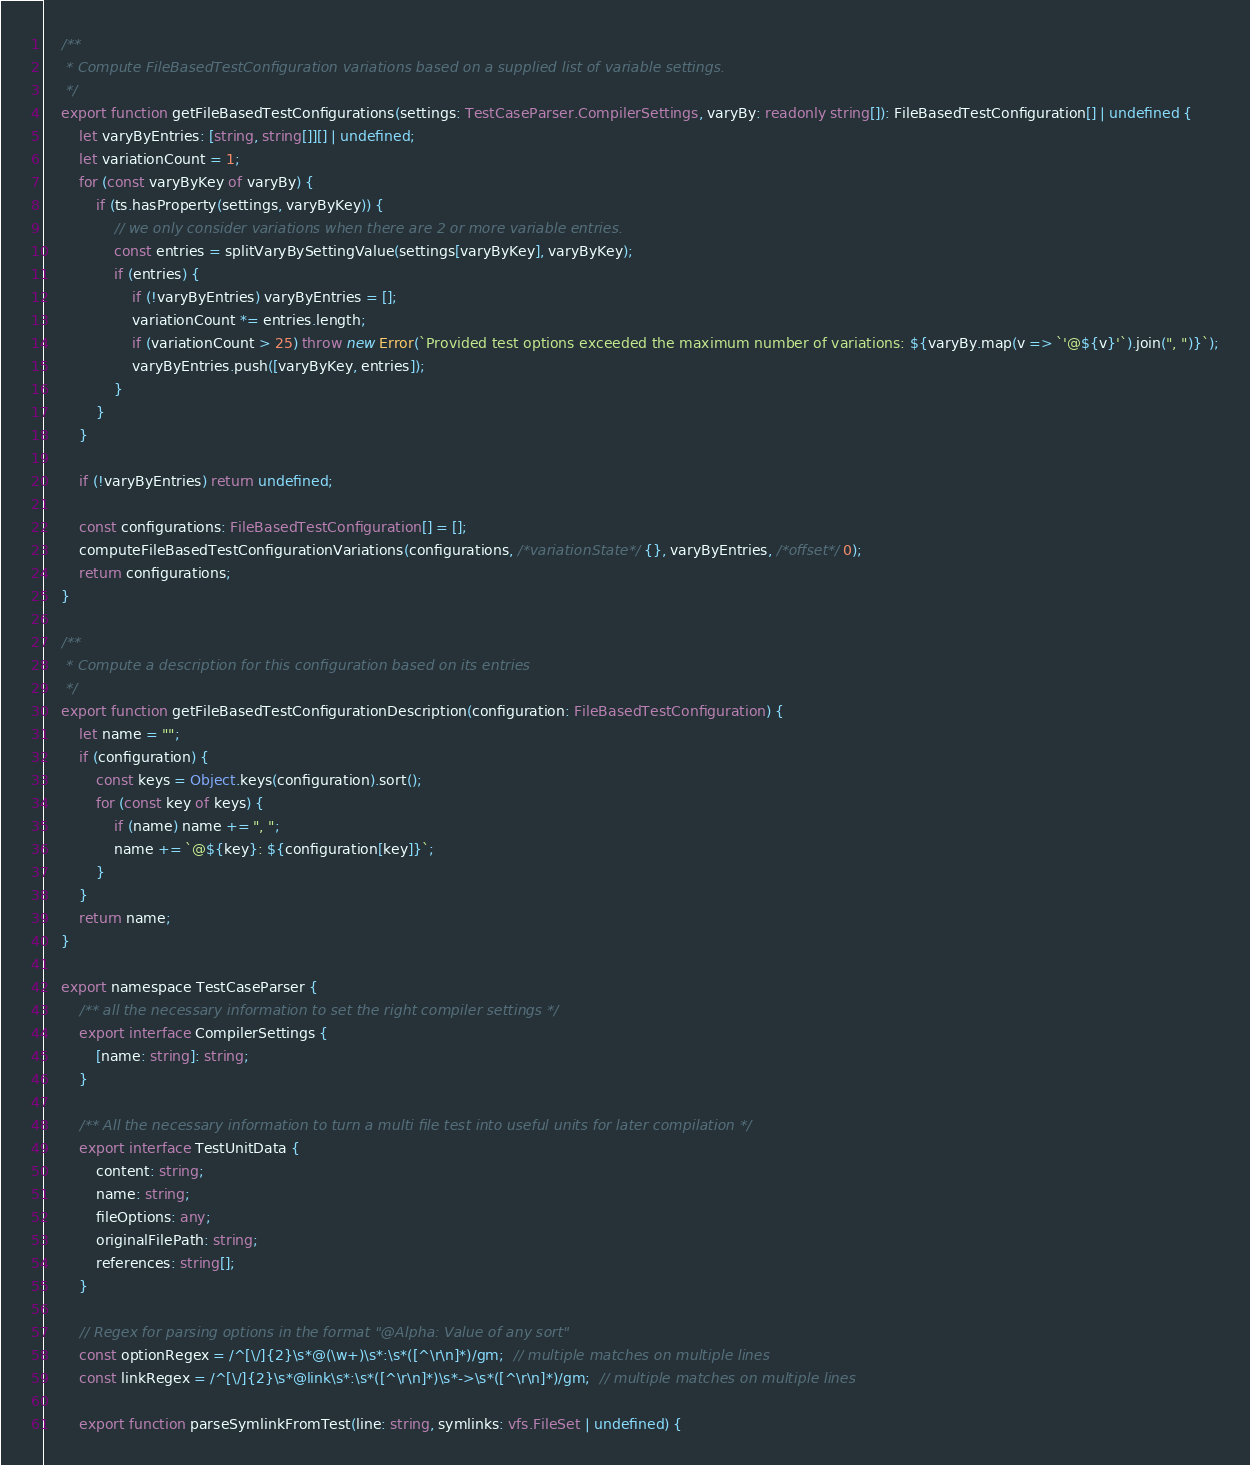Convert code to text. <code><loc_0><loc_0><loc_500><loc_500><_TypeScript_>
    /**
     * Compute FileBasedTestConfiguration variations based on a supplied list of variable settings.
     */
    export function getFileBasedTestConfigurations(settings: TestCaseParser.CompilerSettings, varyBy: readonly string[]): FileBasedTestConfiguration[] | undefined {
        let varyByEntries: [string, string[]][] | undefined;
        let variationCount = 1;
        for (const varyByKey of varyBy) {
            if (ts.hasProperty(settings, varyByKey)) {
                // we only consider variations when there are 2 or more variable entries.
                const entries = splitVaryBySettingValue(settings[varyByKey], varyByKey);
                if (entries) {
                    if (!varyByEntries) varyByEntries = [];
                    variationCount *= entries.length;
                    if (variationCount > 25) throw new Error(`Provided test options exceeded the maximum number of variations: ${varyBy.map(v => `'@${v}'`).join(", ")}`);
                    varyByEntries.push([varyByKey, entries]);
                }
            }
        }

        if (!varyByEntries) return undefined;

        const configurations: FileBasedTestConfiguration[] = [];
        computeFileBasedTestConfigurationVariations(configurations, /*variationState*/ {}, varyByEntries, /*offset*/ 0);
        return configurations;
    }

    /**
     * Compute a description for this configuration based on its entries
     */
    export function getFileBasedTestConfigurationDescription(configuration: FileBasedTestConfiguration) {
        let name = "";
        if (configuration) {
            const keys = Object.keys(configuration).sort();
            for (const key of keys) {
                if (name) name += ", ";
                name += `@${key}: ${configuration[key]}`;
            }
        }
        return name;
    }

    export namespace TestCaseParser {
        /** all the necessary information to set the right compiler settings */
        export interface CompilerSettings {
            [name: string]: string;
        }

        /** All the necessary information to turn a multi file test into useful units for later compilation */
        export interface TestUnitData {
            content: string;
            name: string;
            fileOptions: any;
            originalFilePath: string;
            references: string[];
        }

        // Regex for parsing options in the format "@Alpha: Value of any sort"
        const optionRegex = /^[\/]{2}\s*@(\w+)\s*:\s*([^\r\n]*)/gm;  // multiple matches on multiple lines
        const linkRegex = /^[\/]{2}\s*@link\s*:\s*([^\r\n]*)\s*->\s*([^\r\n]*)/gm;  // multiple matches on multiple lines

        export function parseSymlinkFromTest(line: string, symlinks: vfs.FileSet | undefined) {</code> 